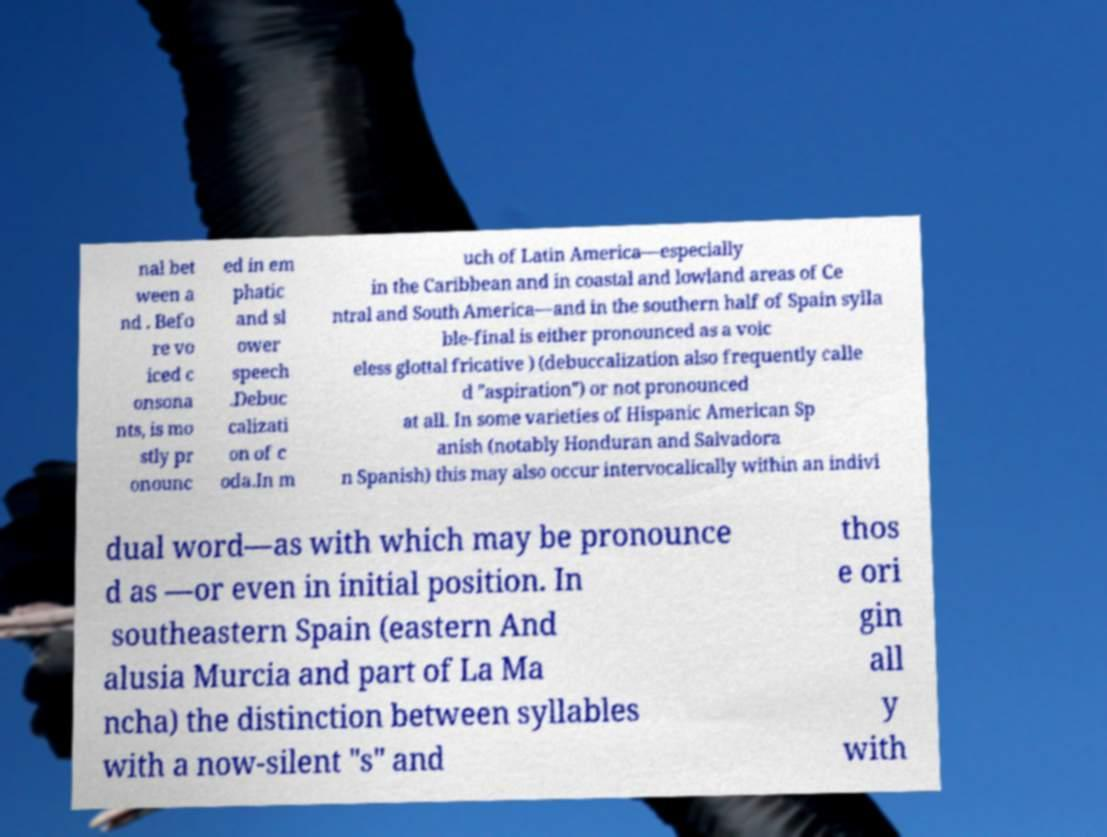What messages or text are displayed in this image? I need them in a readable, typed format. nal bet ween a nd . Befo re vo iced c onsona nts, is mo stly pr onounc ed in em phatic and sl ower speech .Debuc calizati on of c oda.In m uch of Latin America—especially in the Caribbean and in coastal and lowland areas of Ce ntral and South America—and in the southern half of Spain sylla ble-final is either pronounced as a voic eless glottal fricative ) (debuccalization also frequently calle d "aspiration") or not pronounced at all. In some varieties of Hispanic American Sp anish (notably Honduran and Salvadora n Spanish) this may also occur intervocalically within an indivi dual word—as with which may be pronounce d as —or even in initial position. In southeastern Spain (eastern And alusia Murcia and part of La Ma ncha) the distinction between syllables with a now-silent "s" and thos e ori gin all y with 